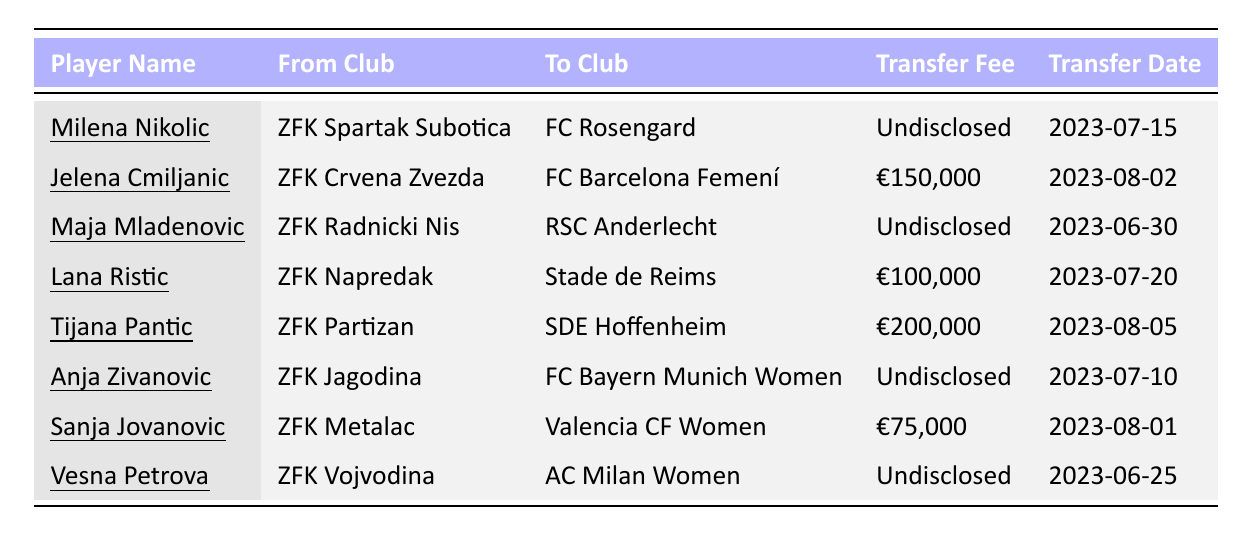What is the transfer fee for Tijana Pantic? According to the table, Tijana Pantic's transfer fee is €200,000.
Answer: €200,000 Who did Jelena Cmiljanic transfer to? The table shows that Jelena Cmiljanic transferred to FC Barcelona Femení.
Answer: FC Barcelona Femení How many players transferred for an undisclosed fee? Reviewing the table, there are four players with an undisclosed transfer fee (Milena Nikolic, Maja Mladenovic, Anja Zivanovic, Vesna Petrova).
Answer: 4 What is the average transfer fee among the known figures? The known transfer fees are €150,000, €100,000, €200,000, and €75,000, which sum up to €525,000. There are 4 known values, so the average is €525,000/4 = €131,250.
Answer: €131,250 Which player transferred from ZFK Radnicki Nis? The table indicates that Maja Mladenovic is the player who transferred from ZFK Radnicki Nis to RSC Anderlecht.
Answer: Maja Mladenovic Is there any player who transferred to AC Milan Women? Yes, Vesna Petrova is the player who transferred to AC Milan Women from ZFK Vojvodina.
Answer: Yes What is the earliest transfer date in the table? By checking the transfer dates, the earliest one is 2023-06-25 for Vesna Petrova's transfer.
Answer: 2023-06-25 Which club received the highest transfer fee? The highest transfer fee listed is for Tijana Pantic, which is €200,000, meaning ZFK Partizan received this amount.
Answer: ZFK Partizan Among all transfers, who moved to the FC Bayern Munich Women? Referring to the table, Anja Zivanovic transferred to FC Bayern Munich Women.
Answer: Anja Zivanovic If we only consider the transfer fees mentioned, what is the total amount received from transfers? The total of known transfer fees is €150,000 + €100,000 + €200,000 + €75,000 = €525,000. The undisclosed transfers do not contribute to this total.
Answer: €525,000 